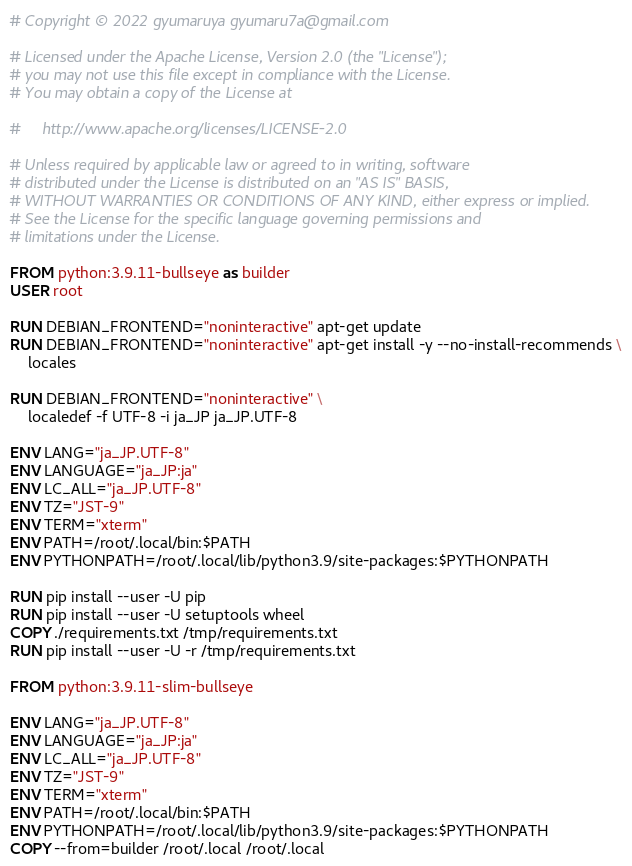Convert code to text. <code><loc_0><loc_0><loc_500><loc_500><_Dockerfile_># Copyright © 2022 gyumaruya gyumaru7a@gmail.com

# Licensed under the Apache License, Version 2.0 (the "License");
# you may not use this file except in compliance with the License.
# You may obtain a copy of the License at

#     http://www.apache.org/licenses/LICENSE-2.0

# Unless required by applicable law or agreed to in writing, software
# distributed under the License is distributed on an "AS IS" BASIS,
# WITHOUT WARRANTIES OR CONDITIONS OF ANY KIND, either express or implied.
# See the License for the specific language governing permissions and
# limitations under the License.

FROM python:3.9.11-bullseye as builder
USER root

RUN DEBIAN_FRONTEND="noninteractive" apt-get update
RUN DEBIAN_FRONTEND="noninteractive" apt-get install -y --no-install-recommends \
    locales

RUN DEBIAN_FRONTEND="noninteractive" \
    localedef -f UTF-8 -i ja_JP ja_JP.UTF-8

ENV LANG="ja_JP.UTF-8"
ENV LANGUAGE="ja_JP:ja"
ENV LC_ALL="ja_JP.UTF-8"
ENV TZ="JST-9"
ENV TERM="xterm"
ENV PATH=/root/.local/bin:$PATH
ENV PYTHONPATH=/root/.local/lib/python3.9/site-packages:$PYTHONPATH

RUN pip install --user -U pip
RUN pip install --user -U setuptools wheel
COPY ./requirements.txt /tmp/requirements.txt 
RUN pip install --user -U -r /tmp/requirements.txt 

FROM python:3.9.11-slim-bullseye

ENV LANG="ja_JP.UTF-8"
ENV LANGUAGE="ja_JP:ja"
ENV LC_ALL="ja_JP.UTF-8"
ENV TZ="JST-9"
ENV TERM="xterm"
ENV PATH=/root/.local/bin:$PATH
ENV PYTHONPATH=/root/.local/lib/python3.9/site-packages:$PYTHONPATH
COPY --from=builder /root/.local /root/.local</code> 